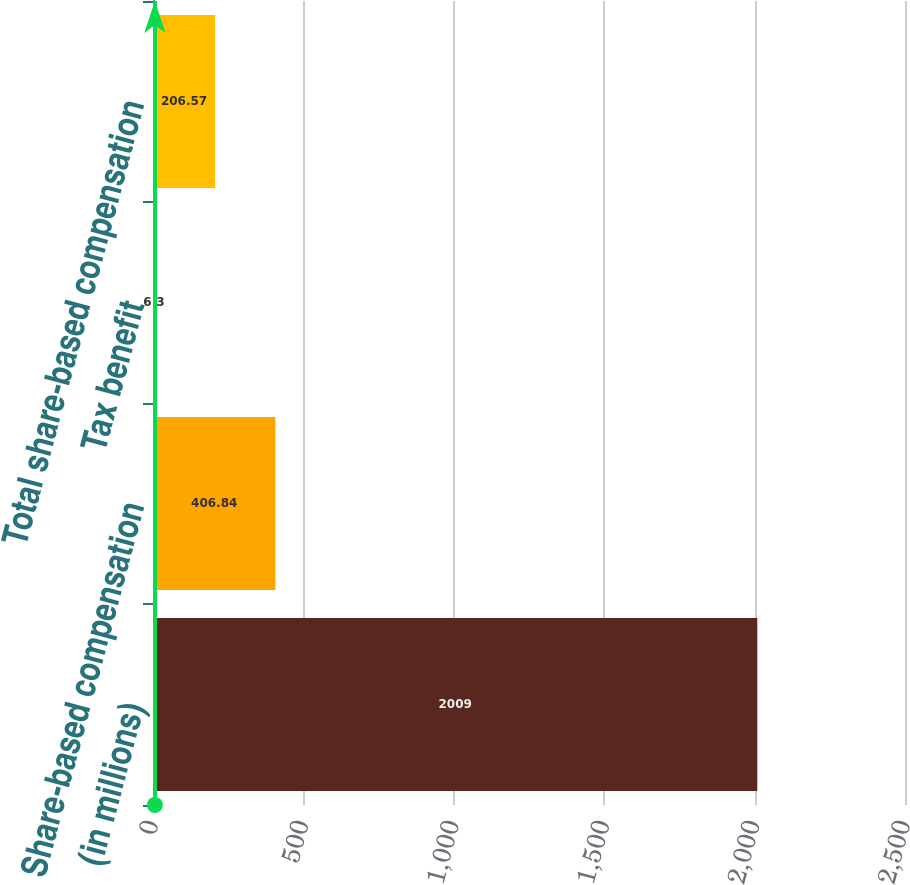<chart> <loc_0><loc_0><loc_500><loc_500><bar_chart><fcel>(in millions)<fcel>Share-based compensation<fcel>Tax benefit<fcel>Total share-based compensation<nl><fcel>2009<fcel>406.84<fcel>6.3<fcel>206.57<nl></chart> 